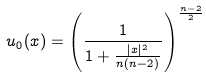<formula> <loc_0><loc_0><loc_500><loc_500>u _ { 0 } ( x ) = \left ( \frac { 1 } { 1 + \frac { | x | ^ { 2 } } { n ( n - 2 ) } } \right ) ^ { \frac { n - 2 } { 2 } }</formula> 